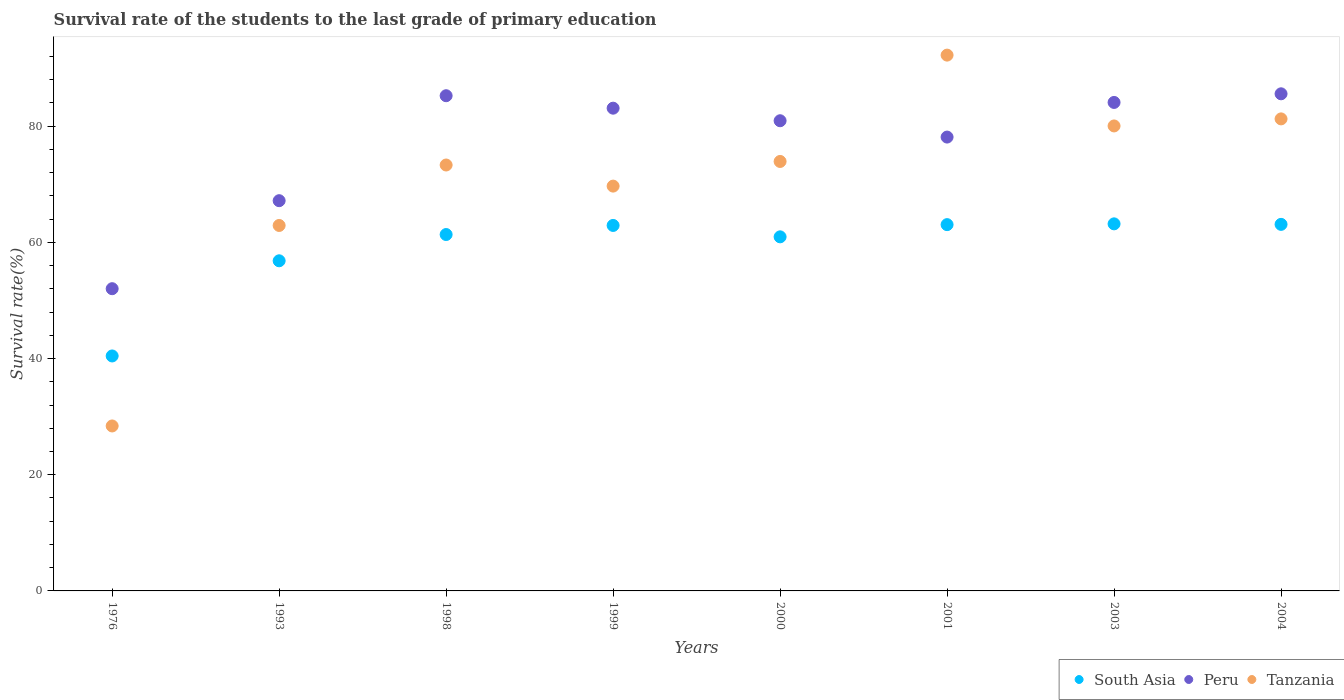Is the number of dotlines equal to the number of legend labels?
Provide a short and direct response. Yes. What is the survival rate of the students in South Asia in 1976?
Your response must be concise. 40.44. Across all years, what is the maximum survival rate of the students in South Asia?
Your answer should be very brief. 63.18. Across all years, what is the minimum survival rate of the students in South Asia?
Offer a terse response. 40.44. In which year was the survival rate of the students in Tanzania minimum?
Give a very brief answer. 1976. What is the total survival rate of the students in South Asia in the graph?
Ensure brevity in your answer.  471.76. What is the difference between the survival rate of the students in South Asia in 1998 and that in 2003?
Make the answer very short. -1.84. What is the difference between the survival rate of the students in Peru in 2004 and the survival rate of the students in South Asia in 2000?
Your response must be concise. 24.62. What is the average survival rate of the students in South Asia per year?
Your response must be concise. 58.97. In the year 1998, what is the difference between the survival rate of the students in South Asia and survival rate of the students in Peru?
Offer a very short reply. -23.89. What is the ratio of the survival rate of the students in South Asia in 2001 to that in 2004?
Provide a short and direct response. 1. Is the survival rate of the students in South Asia in 2001 less than that in 2003?
Ensure brevity in your answer.  Yes. What is the difference between the highest and the second highest survival rate of the students in Tanzania?
Provide a short and direct response. 10.98. What is the difference between the highest and the lowest survival rate of the students in South Asia?
Provide a succinct answer. 22.74. In how many years, is the survival rate of the students in Peru greater than the average survival rate of the students in Peru taken over all years?
Your response must be concise. 6. Is the survival rate of the students in South Asia strictly less than the survival rate of the students in Tanzania over the years?
Give a very brief answer. No. How many dotlines are there?
Ensure brevity in your answer.  3. How many years are there in the graph?
Your answer should be compact. 8. What is the difference between two consecutive major ticks on the Y-axis?
Your answer should be very brief. 20. Does the graph contain grids?
Provide a succinct answer. No. How many legend labels are there?
Provide a succinct answer. 3. How are the legend labels stacked?
Make the answer very short. Horizontal. What is the title of the graph?
Ensure brevity in your answer.  Survival rate of the students to the last grade of primary education. Does "Heavily indebted poor countries" appear as one of the legend labels in the graph?
Your answer should be very brief. No. What is the label or title of the Y-axis?
Your response must be concise. Survival rate(%). What is the Survival rate(%) in South Asia in 1976?
Your answer should be compact. 40.44. What is the Survival rate(%) of Peru in 1976?
Offer a very short reply. 52.02. What is the Survival rate(%) of Tanzania in 1976?
Offer a terse response. 28.39. What is the Survival rate(%) of South Asia in 1993?
Give a very brief answer. 56.82. What is the Survival rate(%) of Peru in 1993?
Your answer should be compact. 67.17. What is the Survival rate(%) of Tanzania in 1993?
Your answer should be very brief. 62.9. What is the Survival rate(%) in South Asia in 1998?
Make the answer very short. 61.34. What is the Survival rate(%) of Peru in 1998?
Your answer should be compact. 85.23. What is the Survival rate(%) in Tanzania in 1998?
Your answer should be compact. 73.31. What is the Survival rate(%) of South Asia in 1999?
Provide a short and direct response. 62.9. What is the Survival rate(%) in Peru in 1999?
Make the answer very short. 83.09. What is the Survival rate(%) of Tanzania in 1999?
Your answer should be very brief. 69.68. What is the Survival rate(%) of South Asia in 2000?
Keep it short and to the point. 60.94. What is the Survival rate(%) of Peru in 2000?
Offer a very short reply. 80.93. What is the Survival rate(%) in Tanzania in 2000?
Offer a terse response. 73.92. What is the Survival rate(%) of South Asia in 2001?
Ensure brevity in your answer.  63.04. What is the Survival rate(%) of Peru in 2001?
Offer a very short reply. 78.11. What is the Survival rate(%) in Tanzania in 2001?
Your answer should be very brief. 92.22. What is the Survival rate(%) in South Asia in 2003?
Provide a short and direct response. 63.18. What is the Survival rate(%) of Peru in 2003?
Your answer should be very brief. 84.08. What is the Survival rate(%) of Tanzania in 2003?
Ensure brevity in your answer.  80.03. What is the Survival rate(%) of South Asia in 2004?
Keep it short and to the point. 63.09. What is the Survival rate(%) of Peru in 2004?
Provide a short and direct response. 85.56. What is the Survival rate(%) in Tanzania in 2004?
Your response must be concise. 81.24. Across all years, what is the maximum Survival rate(%) in South Asia?
Provide a succinct answer. 63.18. Across all years, what is the maximum Survival rate(%) of Peru?
Your response must be concise. 85.56. Across all years, what is the maximum Survival rate(%) of Tanzania?
Ensure brevity in your answer.  92.22. Across all years, what is the minimum Survival rate(%) in South Asia?
Make the answer very short. 40.44. Across all years, what is the minimum Survival rate(%) in Peru?
Ensure brevity in your answer.  52.02. Across all years, what is the minimum Survival rate(%) of Tanzania?
Provide a short and direct response. 28.39. What is the total Survival rate(%) in South Asia in the graph?
Ensure brevity in your answer.  471.76. What is the total Survival rate(%) of Peru in the graph?
Give a very brief answer. 616.18. What is the total Survival rate(%) of Tanzania in the graph?
Your answer should be compact. 561.69. What is the difference between the Survival rate(%) in South Asia in 1976 and that in 1993?
Give a very brief answer. -16.38. What is the difference between the Survival rate(%) of Peru in 1976 and that in 1993?
Offer a very short reply. -15.15. What is the difference between the Survival rate(%) of Tanzania in 1976 and that in 1993?
Ensure brevity in your answer.  -34.51. What is the difference between the Survival rate(%) of South Asia in 1976 and that in 1998?
Ensure brevity in your answer.  -20.9. What is the difference between the Survival rate(%) of Peru in 1976 and that in 1998?
Offer a very short reply. -33.21. What is the difference between the Survival rate(%) of Tanzania in 1976 and that in 1998?
Provide a short and direct response. -44.91. What is the difference between the Survival rate(%) in South Asia in 1976 and that in 1999?
Your answer should be very brief. -22.46. What is the difference between the Survival rate(%) of Peru in 1976 and that in 1999?
Your answer should be very brief. -31.07. What is the difference between the Survival rate(%) of Tanzania in 1976 and that in 1999?
Provide a succinct answer. -41.28. What is the difference between the Survival rate(%) in South Asia in 1976 and that in 2000?
Your answer should be very brief. -20.5. What is the difference between the Survival rate(%) in Peru in 1976 and that in 2000?
Your answer should be compact. -28.91. What is the difference between the Survival rate(%) of Tanzania in 1976 and that in 2000?
Offer a very short reply. -45.52. What is the difference between the Survival rate(%) of South Asia in 1976 and that in 2001?
Give a very brief answer. -22.6. What is the difference between the Survival rate(%) of Peru in 1976 and that in 2001?
Make the answer very short. -26.1. What is the difference between the Survival rate(%) in Tanzania in 1976 and that in 2001?
Your answer should be very brief. -63.83. What is the difference between the Survival rate(%) of South Asia in 1976 and that in 2003?
Make the answer very short. -22.74. What is the difference between the Survival rate(%) of Peru in 1976 and that in 2003?
Ensure brevity in your answer.  -32.06. What is the difference between the Survival rate(%) in Tanzania in 1976 and that in 2003?
Make the answer very short. -51.64. What is the difference between the Survival rate(%) in South Asia in 1976 and that in 2004?
Make the answer very short. -22.65. What is the difference between the Survival rate(%) of Peru in 1976 and that in 2004?
Your answer should be compact. -33.54. What is the difference between the Survival rate(%) of Tanzania in 1976 and that in 2004?
Ensure brevity in your answer.  -52.85. What is the difference between the Survival rate(%) of South Asia in 1993 and that in 1998?
Provide a succinct answer. -4.52. What is the difference between the Survival rate(%) in Peru in 1993 and that in 1998?
Provide a short and direct response. -18.07. What is the difference between the Survival rate(%) of Tanzania in 1993 and that in 1998?
Offer a very short reply. -10.41. What is the difference between the Survival rate(%) in South Asia in 1993 and that in 1999?
Offer a terse response. -6.08. What is the difference between the Survival rate(%) of Peru in 1993 and that in 1999?
Your answer should be very brief. -15.92. What is the difference between the Survival rate(%) of Tanzania in 1993 and that in 1999?
Your answer should be compact. -6.77. What is the difference between the Survival rate(%) in South Asia in 1993 and that in 2000?
Your answer should be compact. -4.12. What is the difference between the Survival rate(%) of Peru in 1993 and that in 2000?
Your answer should be compact. -13.76. What is the difference between the Survival rate(%) in Tanzania in 1993 and that in 2000?
Your answer should be very brief. -11.02. What is the difference between the Survival rate(%) in South Asia in 1993 and that in 2001?
Give a very brief answer. -6.22. What is the difference between the Survival rate(%) of Peru in 1993 and that in 2001?
Provide a short and direct response. -10.95. What is the difference between the Survival rate(%) of Tanzania in 1993 and that in 2001?
Ensure brevity in your answer.  -29.32. What is the difference between the Survival rate(%) in South Asia in 1993 and that in 2003?
Your answer should be very brief. -6.36. What is the difference between the Survival rate(%) in Peru in 1993 and that in 2003?
Your answer should be very brief. -16.91. What is the difference between the Survival rate(%) in Tanzania in 1993 and that in 2003?
Provide a succinct answer. -17.13. What is the difference between the Survival rate(%) of South Asia in 1993 and that in 2004?
Provide a short and direct response. -6.27. What is the difference between the Survival rate(%) of Peru in 1993 and that in 2004?
Your response must be concise. -18.39. What is the difference between the Survival rate(%) in Tanzania in 1993 and that in 2004?
Provide a short and direct response. -18.34. What is the difference between the Survival rate(%) of South Asia in 1998 and that in 1999?
Your response must be concise. -1.56. What is the difference between the Survival rate(%) of Peru in 1998 and that in 1999?
Your answer should be very brief. 2.15. What is the difference between the Survival rate(%) of Tanzania in 1998 and that in 1999?
Provide a succinct answer. 3.63. What is the difference between the Survival rate(%) in South Asia in 1998 and that in 2000?
Give a very brief answer. 0.4. What is the difference between the Survival rate(%) in Peru in 1998 and that in 2000?
Keep it short and to the point. 4.31. What is the difference between the Survival rate(%) in Tanzania in 1998 and that in 2000?
Give a very brief answer. -0.61. What is the difference between the Survival rate(%) in South Asia in 1998 and that in 2001?
Provide a succinct answer. -1.7. What is the difference between the Survival rate(%) of Peru in 1998 and that in 2001?
Offer a very short reply. 7.12. What is the difference between the Survival rate(%) of Tanzania in 1998 and that in 2001?
Give a very brief answer. -18.91. What is the difference between the Survival rate(%) of South Asia in 1998 and that in 2003?
Your answer should be very brief. -1.84. What is the difference between the Survival rate(%) of Peru in 1998 and that in 2003?
Keep it short and to the point. 1.16. What is the difference between the Survival rate(%) of Tanzania in 1998 and that in 2003?
Provide a succinct answer. -6.72. What is the difference between the Survival rate(%) in South Asia in 1998 and that in 2004?
Ensure brevity in your answer.  -1.75. What is the difference between the Survival rate(%) of Peru in 1998 and that in 2004?
Your answer should be very brief. -0.33. What is the difference between the Survival rate(%) in Tanzania in 1998 and that in 2004?
Offer a very short reply. -7.94. What is the difference between the Survival rate(%) in South Asia in 1999 and that in 2000?
Your response must be concise. 1.96. What is the difference between the Survival rate(%) of Peru in 1999 and that in 2000?
Keep it short and to the point. 2.16. What is the difference between the Survival rate(%) in Tanzania in 1999 and that in 2000?
Offer a terse response. -4.24. What is the difference between the Survival rate(%) of South Asia in 1999 and that in 2001?
Give a very brief answer. -0.14. What is the difference between the Survival rate(%) in Peru in 1999 and that in 2001?
Your response must be concise. 4.97. What is the difference between the Survival rate(%) in Tanzania in 1999 and that in 2001?
Provide a succinct answer. -22.55. What is the difference between the Survival rate(%) in South Asia in 1999 and that in 2003?
Ensure brevity in your answer.  -0.27. What is the difference between the Survival rate(%) in Peru in 1999 and that in 2003?
Provide a short and direct response. -0.99. What is the difference between the Survival rate(%) of Tanzania in 1999 and that in 2003?
Keep it short and to the point. -10.36. What is the difference between the Survival rate(%) of South Asia in 1999 and that in 2004?
Your response must be concise. -0.18. What is the difference between the Survival rate(%) in Peru in 1999 and that in 2004?
Offer a very short reply. -2.47. What is the difference between the Survival rate(%) in Tanzania in 1999 and that in 2004?
Give a very brief answer. -11.57. What is the difference between the Survival rate(%) in South Asia in 2000 and that in 2001?
Make the answer very short. -2.1. What is the difference between the Survival rate(%) in Peru in 2000 and that in 2001?
Provide a short and direct response. 2.81. What is the difference between the Survival rate(%) in Tanzania in 2000 and that in 2001?
Give a very brief answer. -18.3. What is the difference between the Survival rate(%) in South Asia in 2000 and that in 2003?
Keep it short and to the point. -2.23. What is the difference between the Survival rate(%) in Peru in 2000 and that in 2003?
Keep it short and to the point. -3.15. What is the difference between the Survival rate(%) in Tanzania in 2000 and that in 2003?
Keep it short and to the point. -6.11. What is the difference between the Survival rate(%) of South Asia in 2000 and that in 2004?
Provide a succinct answer. -2.15. What is the difference between the Survival rate(%) of Peru in 2000 and that in 2004?
Make the answer very short. -4.64. What is the difference between the Survival rate(%) of Tanzania in 2000 and that in 2004?
Offer a terse response. -7.33. What is the difference between the Survival rate(%) of South Asia in 2001 and that in 2003?
Offer a terse response. -0.13. What is the difference between the Survival rate(%) of Peru in 2001 and that in 2003?
Ensure brevity in your answer.  -5.96. What is the difference between the Survival rate(%) of Tanzania in 2001 and that in 2003?
Ensure brevity in your answer.  12.19. What is the difference between the Survival rate(%) in South Asia in 2001 and that in 2004?
Your answer should be very brief. -0.04. What is the difference between the Survival rate(%) in Peru in 2001 and that in 2004?
Make the answer very short. -7.45. What is the difference between the Survival rate(%) of Tanzania in 2001 and that in 2004?
Your answer should be compact. 10.98. What is the difference between the Survival rate(%) of South Asia in 2003 and that in 2004?
Your response must be concise. 0.09. What is the difference between the Survival rate(%) of Peru in 2003 and that in 2004?
Make the answer very short. -1.49. What is the difference between the Survival rate(%) in Tanzania in 2003 and that in 2004?
Offer a very short reply. -1.21. What is the difference between the Survival rate(%) of South Asia in 1976 and the Survival rate(%) of Peru in 1993?
Keep it short and to the point. -26.73. What is the difference between the Survival rate(%) of South Asia in 1976 and the Survival rate(%) of Tanzania in 1993?
Give a very brief answer. -22.46. What is the difference between the Survival rate(%) in Peru in 1976 and the Survival rate(%) in Tanzania in 1993?
Your response must be concise. -10.88. What is the difference between the Survival rate(%) in South Asia in 1976 and the Survival rate(%) in Peru in 1998?
Provide a short and direct response. -44.79. What is the difference between the Survival rate(%) in South Asia in 1976 and the Survival rate(%) in Tanzania in 1998?
Make the answer very short. -32.87. What is the difference between the Survival rate(%) in Peru in 1976 and the Survival rate(%) in Tanzania in 1998?
Make the answer very short. -21.29. What is the difference between the Survival rate(%) of South Asia in 1976 and the Survival rate(%) of Peru in 1999?
Keep it short and to the point. -42.65. What is the difference between the Survival rate(%) in South Asia in 1976 and the Survival rate(%) in Tanzania in 1999?
Your answer should be compact. -29.23. What is the difference between the Survival rate(%) in Peru in 1976 and the Survival rate(%) in Tanzania in 1999?
Provide a succinct answer. -17.66. What is the difference between the Survival rate(%) of South Asia in 1976 and the Survival rate(%) of Peru in 2000?
Your answer should be very brief. -40.48. What is the difference between the Survival rate(%) in South Asia in 1976 and the Survival rate(%) in Tanzania in 2000?
Ensure brevity in your answer.  -33.48. What is the difference between the Survival rate(%) of Peru in 1976 and the Survival rate(%) of Tanzania in 2000?
Your response must be concise. -21.9. What is the difference between the Survival rate(%) in South Asia in 1976 and the Survival rate(%) in Peru in 2001?
Your answer should be compact. -37.67. What is the difference between the Survival rate(%) of South Asia in 1976 and the Survival rate(%) of Tanzania in 2001?
Make the answer very short. -51.78. What is the difference between the Survival rate(%) in Peru in 1976 and the Survival rate(%) in Tanzania in 2001?
Your answer should be compact. -40.2. What is the difference between the Survival rate(%) in South Asia in 1976 and the Survival rate(%) in Peru in 2003?
Your answer should be compact. -43.63. What is the difference between the Survival rate(%) in South Asia in 1976 and the Survival rate(%) in Tanzania in 2003?
Your answer should be very brief. -39.59. What is the difference between the Survival rate(%) of Peru in 1976 and the Survival rate(%) of Tanzania in 2003?
Make the answer very short. -28.01. What is the difference between the Survival rate(%) in South Asia in 1976 and the Survival rate(%) in Peru in 2004?
Your response must be concise. -45.12. What is the difference between the Survival rate(%) of South Asia in 1976 and the Survival rate(%) of Tanzania in 2004?
Ensure brevity in your answer.  -40.8. What is the difference between the Survival rate(%) in Peru in 1976 and the Survival rate(%) in Tanzania in 2004?
Offer a very short reply. -29.23. What is the difference between the Survival rate(%) of South Asia in 1993 and the Survival rate(%) of Peru in 1998?
Make the answer very short. -28.41. What is the difference between the Survival rate(%) of South Asia in 1993 and the Survival rate(%) of Tanzania in 1998?
Make the answer very short. -16.49. What is the difference between the Survival rate(%) in Peru in 1993 and the Survival rate(%) in Tanzania in 1998?
Your answer should be very brief. -6.14. What is the difference between the Survival rate(%) of South Asia in 1993 and the Survival rate(%) of Peru in 1999?
Keep it short and to the point. -26.27. What is the difference between the Survival rate(%) in South Asia in 1993 and the Survival rate(%) in Tanzania in 1999?
Your answer should be compact. -12.85. What is the difference between the Survival rate(%) in Peru in 1993 and the Survival rate(%) in Tanzania in 1999?
Provide a short and direct response. -2.51. What is the difference between the Survival rate(%) of South Asia in 1993 and the Survival rate(%) of Peru in 2000?
Offer a very short reply. -24.11. What is the difference between the Survival rate(%) of South Asia in 1993 and the Survival rate(%) of Tanzania in 2000?
Offer a terse response. -17.1. What is the difference between the Survival rate(%) in Peru in 1993 and the Survival rate(%) in Tanzania in 2000?
Offer a terse response. -6.75. What is the difference between the Survival rate(%) of South Asia in 1993 and the Survival rate(%) of Peru in 2001?
Your answer should be very brief. -21.29. What is the difference between the Survival rate(%) in South Asia in 1993 and the Survival rate(%) in Tanzania in 2001?
Keep it short and to the point. -35.4. What is the difference between the Survival rate(%) of Peru in 1993 and the Survival rate(%) of Tanzania in 2001?
Make the answer very short. -25.05. What is the difference between the Survival rate(%) of South Asia in 1993 and the Survival rate(%) of Peru in 2003?
Your answer should be very brief. -27.26. What is the difference between the Survival rate(%) of South Asia in 1993 and the Survival rate(%) of Tanzania in 2003?
Offer a very short reply. -23.21. What is the difference between the Survival rate(%) in Peru in 1993 and the Survival rate(%) in Tanzania in 2003?
Keep it short and to the point. -12.87. What is the difference between the Survival rate(%) of South Asia in 1993 and the Survival rate(%) of Peru in 2004?
Give a very brief answer. -28.74. What is the difference between the Survival rate(%) of South Asia in 1993 and the Survival rate(%) of Tanzania in 2004?
Your answer should be compact. -24.42. What is the difference between the Survival rate(%) in Peru in 1993 and the Survival rate(%) in Tanzania in 2004?
Your answer should be compact. -14.08. What is the difference between the Survival rate(%) in South Asia in 1998 and the Survival rate(%) in Peru in 1999?
Make the answer very short. -21.75. What is the difference between the Survival rate(%) of South Asia in 1998 and the Survival rate(%) of Tanzania in 1999?
Provide a succinct answer. -8.33. What is the difference between the Survival rate(%) of Peru in 1998 and the Survival rate(%) of Tanzania in 1999?
Your answer should be compact. 15.56. What is the difference between the Survival rate(%) of South Asia in 1998 and the Survival rate(%) of Peru in 2000?
Keep it short and to the point. -19.58. What is the difference between the Survival rate(%) in South Asia in 1998 and the Survival rate(%) in Tanzania in 2000?
Offer a terse response. -12.58. What is the difference between the Survival rate(%) in Peru in 1998 and the Survival rate(%) in Tanzania in 2000?
Ensure brevity in your answer.  11.32. What is the difference between the Survival rate(%) of South Asia in 1998 and the Survival rate(%) of Peru in 2001?
Offer a very short reply. -16.77. What is the difference between the Survival rate(%) of South Asia in 1998 and the Survival rate(%) of Tanzania in 2001?
Offer a terse response. -30.88. What is the difference between the Survival rate(%) in Peru in 1998 and the Survival rate(%) in Tanzania in 2001?
Make the answer very short. -6.99. What is the difference between the Survival rate(%) of South Asia in 1998 and the Survival rate(%) of Peru in 2003?
Offer a terse response. -22.73. What is the difference between the Survival rate(%) in South Asia in 1998 and the Survival rate(%) in Tanzania in 2003?
Your answer should be very brief. -18.69. What is the difference between the Survival rate(%) of Peru in 1998 and the Survival rate(%) of Tanzania in 2003?
Make the answer very short. 5.2. What is the difference between the Survival rate(%) of South Asia in 1998 and the Survival rate(%) of Peru in 2004?
Your answer should be compact. -24.22. What is the difference between the Survival rate(%) in South Asia in 1998 and the Survival rate(%) in Tanzania in 2004?
Your answer should be compact. -19.9. What is the difference between the Survival rate(%) of Peru in 1998 and the Survival rate(%) of Tanzania in 2004?
Offer a terse response. 3.99. What is the difference between the Survival rate(%) of South Asia in 1999 and the Survival rate(%) of Peru in 2000?
Provide a short and direct response. -18.02. What is the difference between the Survival rate(%) of South Asia in 1999 and the Survival rate(%) of Tanzania in 2000?
Give a very brief answer. -11.01. What is the difference between the Survival rate(%) in Peru in 1999 and the Survival rate(%) in Tanzania in 2000?
Provide a short and direct response. 9.17. What is the difference between the Survival rate(%) of South Asia in 1999 and the Survival rate(%) of Peru in 2001?
Your answer should be compact. -15.21. What is the difference between the Survival rate(%) in South Asia in 1999 and the Survival rate(%) in Tanzania in 2001?
Give a very brief answer. -29.32. What is the difference between the Survival rate(%) of Peru in 1999 and the Survival rate(%) of Tanzania in 2001?
Provide a succinct answer. -9.13. What is the difference between the Survival rate(%) in South Asia in 1999 and the Survival rate(%) in Peru in 2003?
Offer a very short reply. -21.17. What is the difference between the Survival rate(%) in South Asia in 1999 and the Survival rate(%) in Tanzania in 2003?
Offer a very short reply. -17.13. What is the difference between the Survival rate(%) of Peru in 1999 and the Survival rate(%) of Tanzania in 2003?
Your answer should be very brief. 3.06. What is the difference between the Survival rate(%) in South Asia in 1999 and the Survival rate(%) in Peru in 2004?
Provide a short and direct response. -22.66. What is the difference between the Survival rate(%) in South Asia in 1999 and the Survival rate(%) in Tanzania in 2004?
Give a very brief answer. -18.34. What is the difference between the Survival rate(%) in Peru in 1999 and the Survival rate(%) in Tanzania in 2004?
Ensure brevity in your answer.  1.84. What is the difference between the Survival rate(%) of South Asia in 2000 and the Survival rate(%) of Peru in 2001?
Provide a short and direct response. -17.17. What is the difference between the Survival rate(%) in South Asia in 2000 and the Survival rate(%) in Tanzania in 2001?
Provide a succinct answer. -31.28. What is the difference between the Survival rate(%) of Peru in 2000 and the Survival rate(%) of Tanzania in 2001?
Make the answer very short. -11.3. What is the difference between the Survival rate(%) in South Asia in 2000 and the Survival rate(%) in Peru in 2003?
Provide a short and direct response. -23.13. What is the difference between the Survival rate(%) in South Asia in 2000 and the Survival rate(%) in Tanzania in 2003?
Provide a short and direct response. -19.09. What is the difference between the Survival rate(%) in Peru in 2000 and the Survival rate(%) in Tanzania in 2003?
Your response must be concise. 0.89. What is the difference between the Survival rate(%) in South Asia in 2000 and the Survival rate(%) in Peru in 2004?
Ensure brevity in your answer.  -24.62. What is the difference between the Survival rate(%) in South Asia in 2000 and the Survival rate(%) in Tanzania in 2004?
Your response must be concise. -20.3. What is the difference between the Survival rate(%) of Peru in 2000 and the Survival rate(%) of Tanzania in 2004?
Your answer should be very brief. -0.32. What is the difference between the Survival rate(%) in South Asia in 2001 and the Survival rate(%) in Peru in 2003?
Give a very brief answer. -21.03. What is the difference between the Survival rate(%) in South Asia in 2001 and the Survival rate(%) in Tanzania in 2003?
Ensure brevity in your answer.  -16.99. What is the difference between the Survival rate(%) of Peru in 2001 and the Survival rate(%) of Tanzania in 2003?
Provide a succinct answer. -1.92. What is the difference between the Survival rate(%) in South Asia in 2001 and the Survival rate(%) in Peru in 2004?
Make the answer very short. -22.52. What is the difference between the Survival rate(%) of South Asia in 2001 and the Survival rate(%) of Tanzania in 2004?
Ensure brevity in your answer.  -18.2. What is the difference between the Survival rate(%) of Peru in 2001 and the Survival rate(%) of Tanzania in 2004?
Keep it short and to the point. -3.13. What is the difference between the Survival rate(%) in South Asia in 2003 and the Survival rate(%) in Peru in 2004?
Provide a succinct answer. -22.38. What is the difference between the Survival rate(%) in South Asia in 2003 and the Survival rate(%) in Tanzania in 2004?
Your response must be concise. -18.07. What is the difference between the Survival rate(%) in Peru in 2003 and the Survival rate(%) in Tanzania in 2004?
Keep it short and to the point. 2.83. What is the average Survival rate(%) of South Asia per year?
Offer a very short reply. 58.97. What is the average Survival rate(%) of Peru per year?
Your answer should be very brief. 77.02. What is the average Survival rate(%) of Tanzania per year?
Your answer should be very brief. 70.21. In the year 1976, what is the difference between the Survival rate(%) in South Asia and Survival rate(%) in Peru?
Ensure brevity in your answer.  -11.58. In the year 1976, what is the difference between the Survival rate(%) of South Asia and Survival rate(%) of Tanzania?
Give a very brief answer. 12.05. In the year 1976, what is the difference between the Survival rate(%) of Peru and Survival rate(%) of Tanzania?
Provide a short and direct response. 23.62. In the year 1993, what is the difference between the Survival rate(%) of South Asia and Survival rate(%) of Peru?
Offer a terse response. -10.35. In the year 1993, what is the difference between the Survival rate(%) in South Asia and Survival rate(%) in Tanzania?
Give a very brief answer. -6.08. In the year 1993, what is the difference between the Survival rate(%) in Peru and Survival rate(%) in Tanzania?
Your response must be concise. 4.27. In the year 1998, what is the difference between the Survival rate(%) of South Asia and Survival rate(%) of Peru?
Give a very brief answer. -23.89. In the year 1998, what is the difference between the Survival rate(%) in South Asia and Survival rate(%) in Tanzania?
Provide a succinct answer. -11.97. In the year 1998, what is the difference between the Survival rate(%) of Peru and Survival rate(%) of Tanzania?
Offer a very short reply. 11.93. In the year 1999, what is the difference between the Survival rate(%) of South Asia and Survival rate(%) of Peru?
Ensure brevity in your answer.  -20.18. In the year 1999, what is the difference between the Survival rate(%) of South Asia and Survival rate(%) of Tanzania?
Your answer should be compact. -6.77. In the year 1999, what is the difference between the Survival rate(%) in Peru and Survival rate(%) in Tanzania?
Provide a short and direct response. 13.41. In the year 2000, what is the difference between the Survival rate(%) in South Asia and Survival rate(%) in Peru?
Keep it short and to the point. -19.98. In the year 2000, what is the difference between the Survival rate(%) in South Asia and Survival rate(%) in Tanzania?
Make the answer very short. -12.97. In the year 2000, what is the difference between the Survival rate(%) in Peru and Survival rate(%) in Tanzania?
Give a very brief answer. 7.01. In the year 2001, what is the difference between the Survival rate(%) of South Asia and Survival rate(%) of Peru?
Your answer should be compact. -15.07. In the year 2001, what is the difference between the Survival rate(%) in South Asia and Survival rate(%) in Tanzania?
Ensure brevity in your answer.  -29.18. In the year 2001, what is the difference between the Survival rate(%) of Peru and Survival rate(%) of Tanzania?
Your response must be concise. -14.11. In the year 2003, what is the difference between the Survival rate(%) in South Asia and Survival rate(%) in Peru?
Provide a short and direct response. -20.9. In the year 2003, what is the difference between the Survival rate(%) in South Asia and Survival rate(%) in Tanzania?
Your response must be concise. -16.85. In the year 2003, what is the difference between the Survival rate(%) of Peru and Survival rate(%) of Tanzania?
Provide a succinct answer. 4.04. In the year 2004, what is the difference between the Survival rate(%) in South Asia and Survival rate(%) in Peru?
Your answer should be compact. -22.47. In the year 2004, what is the difference between the Survival rate(%) in South Asia and Survival rate(%) in Tanzania?
Keep it short and to the point. -18.16. In the year 2004, what is the difference between the Survival rate(%) in Peru and Survival rate(%) in Tanzania?
Your answer should be compact. 4.32. What is the ratio of the Survival rate(%) of South Asia in 1976 to that in 1993?
Give a very brief answer. 0.71. What is the ratio of the Survival rate(%) in Peru in 1976 to that in 1993?
Provide a short and direct response. 0.77. What is the ratio of the Survival rate(%) of Tanzania in 1976 to that in 1993?
Ensure brevity in your answer.  0.45. What is the ratio of the Survival rate(%) of South Asia in 1976 to that in 1998?
Provide a succinct answer. 0.66. What is the ratio of the Survival rate(%) in Peru in 1976 to that in 1998?
Ensure brevity in your answer.  0.61. What is the ratio of the Survival rate(%) of Tanzania in 1976 to that in 1998?
Provide a succinct answer. 0.39. What is the ratio of the Survival rate(%) in South Asia in 1976 to that in 1999?
Provide a succinct answer. 0.64. What is the ratio of the Survival rate(%) in Peru in 1976 to that in 1999?
Your response must be concise. 0.63. What is the ratio of the Survival rate(%) in Tanzania in 1976 to that in 1999?
Your answer should be compact. 0.41. What is the ratio of the Survival rate(%) of South Asia in 1976 to that in 2000?
Your answer should be compact. 0.66. What is the ratio of the Survival rate(%) in Peru in 1976 to that in 2000?
Provide a short and direct response. 0.64. What is the ratio of the Survival rate(%) in Tanzania in 1976 to that in 2000?
Offer a terse response. 0.38. What is the ratio of the Survival rate(%) in South Asia in 1976 to that in 2001?
Provide a succinct answer. 0.64. What is the ratio of the Survival rate(%) in Peru in 1976 to that in 2001?
Your answer should be very brief. 0.67. What is the ratio of the Survival rate(%) of Tanzania in 1976 to that in 2001?
Make the answer very short. 0.31. What is the ratio of the Survival rate(%) of South Asia in 1976 to that in 2003?
Provide a succinct answer. 0.64. What is the ratio of the Survival rate(%) of Peru in 1976 to that in 2003?
Your answer should be very brief. 0.62. What is the ratio of the Survival rate(%) of Tanzania in 1976 to that in 2003?
Offer a terse response. 0.35. What is the ratio of the Survival rate(%) of South Asia in 1976 to that in 2004?
Your answer should be compact. 0.64. What is the ratio of the Survival rate(%) in Peru in 1976 to that in 2004?
Your answer should be very brief. 0.61. What is the ratio of the Survival rate(%) in Tanzania in 1976 to that in 2004?
Give a very brief answer. 0.35. What is the ratio of the Survival rate(%) of South Asia in 1993 to that in 1998?
Offer a very short reply. 0.93. What is the ratio of the Survival rate(%) of Peru in 1993 to that in 1998?
Ensure brevity in your answer.  0.79. What is the ratio of the Survival rate(%) in Tanzania in 1993 to that in 1998?
Offer a terse response. 0.86. What is the ratio of the Survival rate(%) in South Asia in 1993 to that in 1999?
Make the answer very short. 0.9. What is the ratio of the Survival rate(%) in Peru in 1993 to that in 1999?
Give a very brief answer. 0.81. What is the ratio of the Survival rate(%) of Tanzania in 1993 to that in 1999?
Your answer should be compact. 0.9. What is the ratio of the Survival rate(%) in South Asia in 1993 to that in 2000?
Your response must be concise. 0.93. What is the ratio of the Survival rate(%) in Peru in 1993 to that in 2000?
Make the answer very short. 0.83. What is the ratio of the Survival rate(%) in Tanzania in 1993 to that in 2000?
Your response must be concise. 0.85. What is the ratio of the Survival rate(%) of South Asia in 1993 to that in 2001?
Provide a short and direct response. 0.9. What is the ratio of the Survival rate(%) in Peru in 1993 to that in 2001?
Provide a short and direct response. 0.86. What is the ratio of the Survival rate(%) in Tanzania in 1993 to that in 2001?
Provide a short and direct response. 0.68. What is the ratio of the Survival rate(%) of South Asia in 1993 to that in 2003?
Your response must be concise. 0.9. What is the ratio of the Survival rate(%) in Peru in 1993 to that in 2003?
Provide a succinct answer. 0.8. What is the ratio of the Survival rate(%) in Tanzania in 1993 to that in 2003?
Provide a short and direct response. 0.79. What is the ratio of the Survival rate(%) in South Asia in 1993 to that in 2004?
Ensure brevity in your answer.  0.9. What is the ratio of the Survival rate(%) of Peru in 1993 to that in 2004?
Offer a very short reply. 0.79. What is the ratio of the Survival rate(%) of Tanzania in 1993 to that in 2004?
Your answer should be very brief. 0.77. What is the ratio of the Survival rate(%) in South Asia in 1998 to that in 1999?
Offer a very short reply. 0.98. What is the ratio of the Survival rate(%) of Peru in 1998 to that in 1999?
Keep it short and to the point. 1.03. What is the ratio of the Survival rate(%) in Tanzania in 1998 to that in 1999?
Your answer should be very brief. 1.05. What is the ratio of the Survival rate(%) in South Asia in 1998 to that in 2000?
Your answer should be compact. 1.01. What is the ratio of the Survival rate(%) in Peru in 1998 to that in 2000?
Provide a short and direct response. 1.05. What is the ratio of the Survival rate(%) in Tanzania in 1998 to that in 2000?
Provide a short and direct response. 0.99. What is the ratio of the Survival rate(%) in Peru in 1998 to that in 2001?
Provide a short and direct response. 1.09. What is the ratio of the Survival rate(%) of Tanzania in 1998 to that in 2001?
Your answer should be compact. 0.79. What is the ratio of the Survival rate(%) in South Asia in 1998 to that in 2003?
Make the answer very short. 0.97. What is the ratio of the Survival rate(%) in Peru in 1998 to that in 2003?
Provide a succinct answer. 1.01. What is the ratio of the Survival rate(%) in Tanzania in 1998 to that in 2003?
Your answer should be very brief. 0.92. What is the ratio of the Survival rate(%) in South Asia in 1998 to that in 2004?
Keep it short and to the point. 0.97. What is the ratio of the Survival rate(%) of Tanzania in 1998 to that in 2004?
Your answer should be compact. 0.9. What is the ratio of the Survival rate(%) in South Asia in 1999 to that in 2000?
Offer a terse response. 1.03. What is the ratio of the Survival rate(%) of Peru in 1999 to that in 2000?
Provide a succinct answer. 1.03. What is the ratio of the Survival rate(%) in Tanzania in 1999 to that in 2000?
Offer a terse response. 0.94. What is the ratio of the Survival rate(%) in Peru in 1999 to that in 2001?
Your response must be concise. 1.06. What is the ratio of the Survival rate(%) in Tanzania in 1999 to that in 2001?
Keep it short and to the point. 0.76. What is the ratio of the Survival rate(%) in South Asia in 1999 to that in 2003?
Your answer should be very brief. 1. What is the ratio of the Survival rate(%) of Peru in 1999 to that in 2003?
Provide a succinct answer. 0.99. What is the ratio of the Survival rate(%) of Tanzania in 1999 to that in 2003?
Your response must be concise. 0.87. What is the ratio of the Survival rate(%) of South Asia in 1999 to that in 2004?
Provide a succinct answer. 1. What is the ratio of the Survival rate(%) of Peru in 1999 to that in 2004?
Ensure brevity in your answer.  0.97. What is the ratio of the Survival rate(%) in Tanzania in 1999 to that in 2004?
Offer a very short reply. 0.86. What is the ratio of the Survival rate(%) of South Asia in 2000 to that in 2001?
Offer a very short reply. 0.97. What is the ratio of the Survival rate(%) of Peru in 2000 to that in 2001?
Give a very brief answer. 1.04. What is the ratio of the Survival rate(%) in Tanzania in 2000 to that in 2001?
Offer a terse response. 0.8. What is the ratio of the Survival rate(%) of South Asia in 2000 to that in 2003?
Your response must be concise. 0.96. What is the ratio of the Survival rate(%) in Peru in 2000 to that in 2003?
Give a very brief answer. 0.96. What is the ratio of the Survival rate(%) of Tanzania in 2000 to that in 2003?
Offer a terse response. 0.92. What is the ratio of the Survival rate(%) of South Asia in 2000 to that in 2004?
Keep it short and to the point. 0.97. What is the ratio of the Survival rate(%) of Peru in 2000 to that in 2004?
Provide a succinct answer. 0.95. What is the ratio of the Survival rate(%) of Tanzania in 2000 to that in 2004?
Make the answer very short. 0.91. What is the ratio of the Survival rate(%) of Peru in 2001 to that in 2003?
Provide a short and direct response. 0.93. What is the ratio of the Survival rate(%) in Tanzania in 2001 to that in 2003?
Provide a succinct answer. 1.15. What is the ratio of the Survival rate(%) of Tanzania in 2001 to that in 2004?
Your answer should be compact. 1.14. What is the ratio of the Survival rate(%) of South Asia in 2003 to that in 2004?
Make the answer very short. 1. What is the ratio of the Survival rate(%) in Peru in 2003 to that in 2004?
Provide a short and direct response. 0.98. What is the ratio of the Survival rate(%) in Tanzania in 2003 to that in 2004?
Offer a terse response. 0.99. What is the difference between the highest and the second highest Survival rate(%) of South Asia?
Your response must be concise. 0.09. What is the difference between the highest and the second highest Survival rate(%) in Peru?
Provide a short and direct response. 0.33. What is the difference between the highest and the second highest Survival rate(%) of Tanzania?
Your response must be concise. 10.98. What is the difference between the highest and the lowest Survival rate(%) in South Asia?
Provide a short and direct response. 22.74. What is the difference between the highest and the lowest Survival rate(%) of Peru?
Offer a terse response. 33.54. What is the difference between the highest and the lowest Survival rate(%) in Tanzania?
Provide a succinct answer. 63.83. 